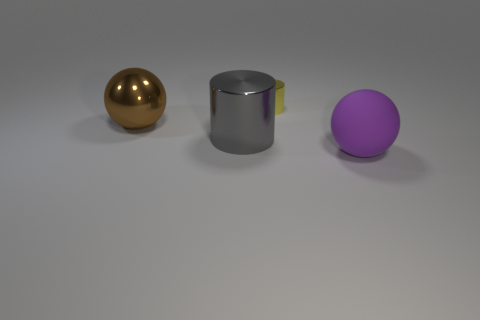Do the large cylinder and the brown thing have the same material?
Provide a short and direct response. Yes. There is a shiny cylinder in front of the large brown metal ball; is it the same size as the sphere on the right side of the yellow object?
Your answer should be compact. Yes. Are there fewer large gray metal objects than small yellow metallic blocks?
Offer a terse response. No. How many matte objects are small objects or brown balls?
Give a very brief answer. 0. Is there a large brown thing behind the big ball that is in front of the large shiny sphere?
Make the answer very short. Yes. Are the large thing on the left side of the big gray object and the tiny yellow cylinder made of the same material?
Offer a very short reply. Yes. Is the matte thing the same color as the big metal cylinder?
Give a very brief answer. No. What size is the metallic object that is behind the sphere on the left side of the small yellow object?
Offer a terse response. Small. Is the material of the large ball that is left of the yellow thing the same as the cylinder that is in front of the tiny yellow cylinder?
Offer a terse response. Yes. There is a yellow shiny thing; how many big purple matte balls are on the left side of it?
Keep it short and to the point. 0. 